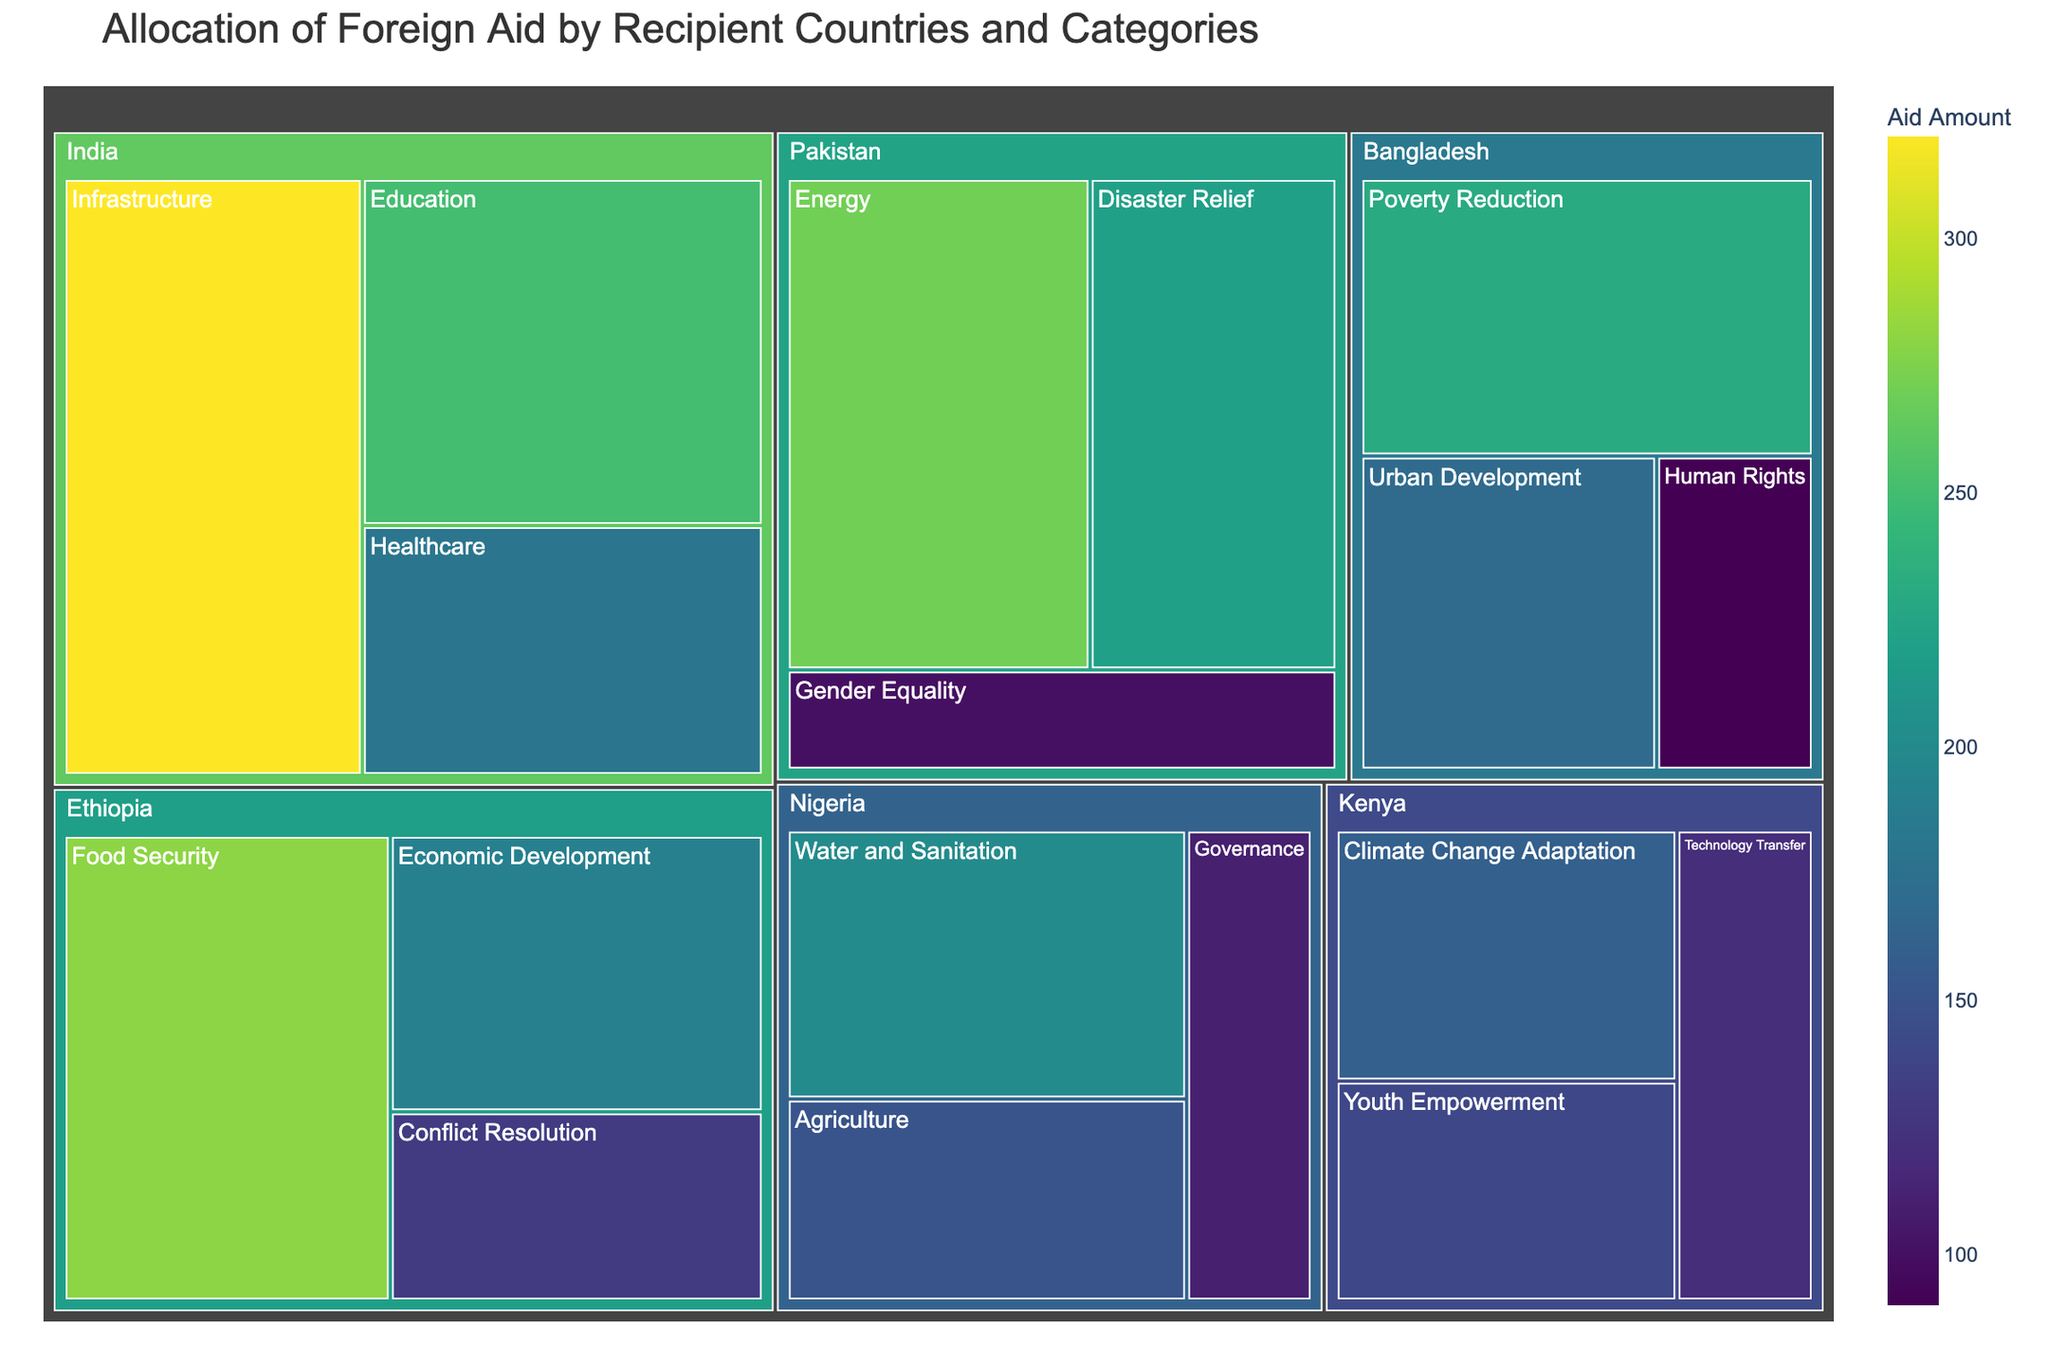What is the color scheme used in the Treemap? The Treemap uses the "Viridis" color scheme, which is a gradient ranging from dark purple to bright yellow, indicating varying aid amounts.
Answer: Viridis Which country receives aid for the most categories? By counting the different aid categories for each country in the Treemap, it is evident that India and Nigeria both receive aid for three categories each.
Answer: India and Nigeria What category does Ethiopia receive the highest amount of aid for? From the Treemap, Ethiopia receives the highest amount of aid for "Food Security," which is the largest rectangle for Ethiopia.
Answer: Food Security Compare the total aid received by India and Nigeria. Which one receives more? Summing up the aid amounts for India (250 for Education, 180 for Healthcare, 320 for Infrastructure) and Nigeria (150 for Agriculture, 200 for Water and Sanitation, 110 for Governance), we get 750 for India and 460 for Nigeria.
Answer: India Which category has the smallest amount of aid across all countries? The smallest rectangle in the Treemap is for "Human Rights" in Bangladesh, with an amount of 90.
Answer: Human Rights What is the visual relationship between the amount of aid and the size of the rectangles in the Treemap? In the Treemap, larger rectangles represent higher amounts of aid, while smaller rectangles represent lower amounts, as indicated by the values in each category.
Answer: Larger rectangles represent higher aid amounts How does the amount of aid for Disaster Relief in Pakistan compare to Education in India? The Treemap shows that Disaster Relief in Pakistan receives 220, while Education in India receives 250, so Education in India receives more aid.
Answer: Education in India Which country receives aid for Gender Equality, and what is the amount? The Treemap shows that Pakistan receives aid for Gender Equality, with an amount of 100.
Answer: Pakistan, 100 What is the total amount of aid received by Bangladesh? Summing up the amounts for Bangladesh (230 for Poverty Reduction, 170 for Urban Development, 90 for Human Rights) gives a total of 230 + 170 + 90 = 490.
Answer: 490 What are the top three categories in terms of aid amount for Ethiopia? By ordering the categories for Ethiopia by descending aid amounts, we have Food Security (280), Economic Development (190), and Conflict Resolution (130).
Answer: Food Security, Economic Development, and Conflict Resolution 